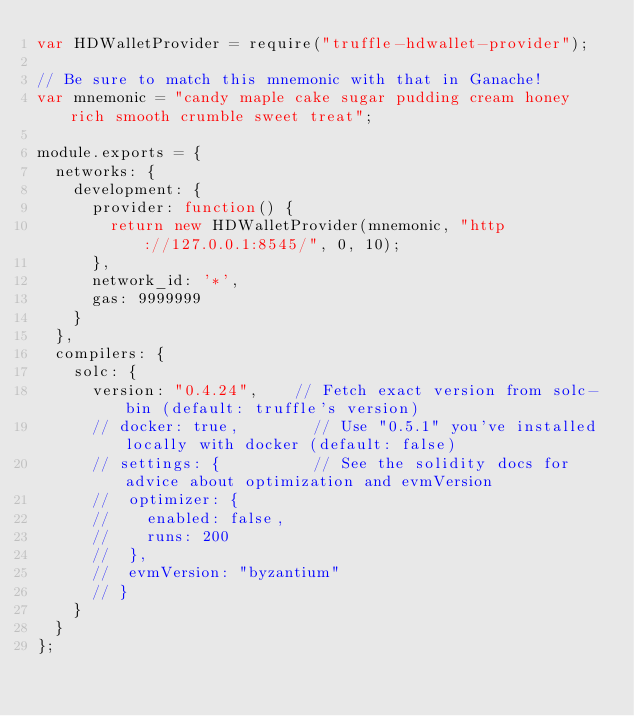Convert code to text. <code><loc_0><loc_0><loc_500><loc_500><_JavaScript_>var HDWalletProvider = require("truffle-hdwallet-provider");

// Be sure to match this mnemonic with that in Ganache!
var mnemonic = "candy maple cake sugar pudding cream honey rich smooth crumble sweet treat";

module.exports = {
  networks: {
    development: {
      provider: function() {
        return new HDWalletProvider(mnemonic, "http://127.0.0.1:8545/", 0, 10);
      },
      network_id: '*',
      gas: 9999999
    }
  },
  compilers: {
    solc: {
      version: "0.4.24",    // Fetch exact version from solc-bin (default: truffle's version)
      // docker: true,        // Use "0.5.1" you've installed locally with docker (default: false)
      // settings: {          // See the solidity docs for advice about optimization and evmVersion
      //  optimizer: {
      //    enabled: false,
      //    runs: 200
      //  },
      //  evmVersion: "byzantium"
      // }
    }
  }
};</code> 